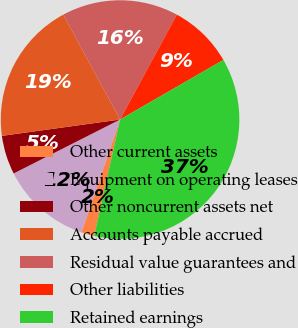<chart> <loc_0><loc_0><loc_500><loc_500><pie_chart><fcel>Other current assets<fcel>Equipment on operating leases<fcel>Other noncurrent assets net<fcel>Accounts payable accrued<fcel>Residual value guarantees and<fcel>Other liabilities<fcel>Retained earnings<nl><fcel>1.78%<fcel>12.28%<fcel>5.28%<fcel>19.29%<fcel>15.79%<fcel>8.78%<fcel>36.8%<nl></chart> 